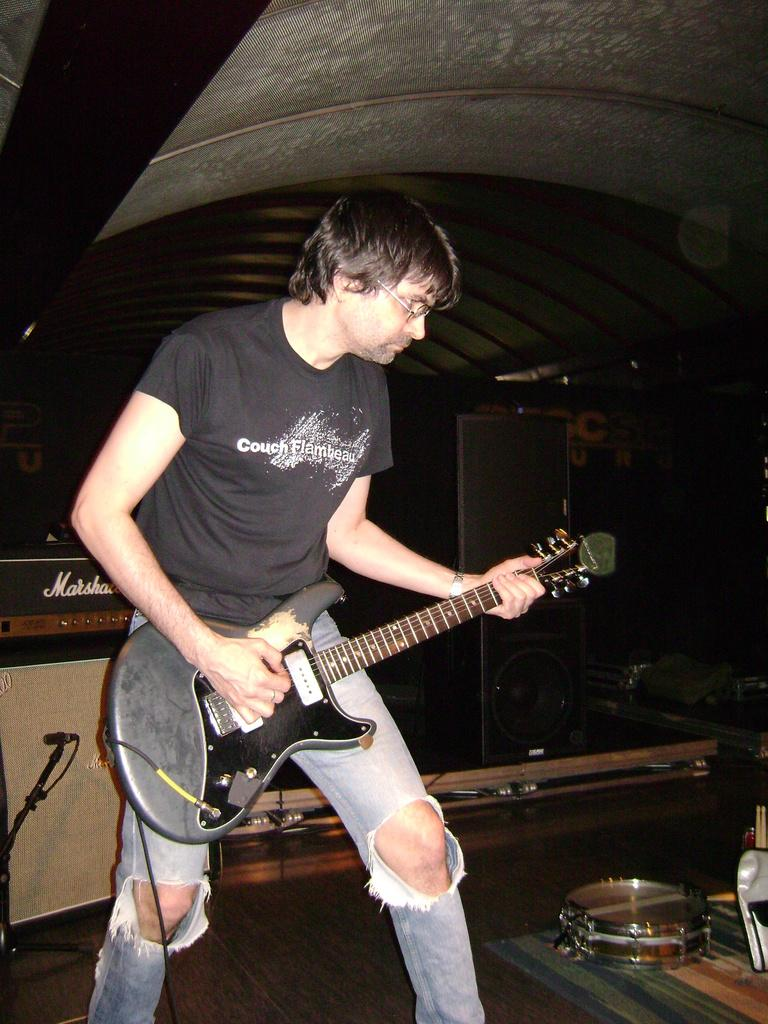What is the man in the image doing? The man is playing a guitar in the image. What can be seen in the background of the image? There is a speaker in the background of the image. What other musical instrument is visible in the image? There is a drum on the right side of the image. What type of umbrella is the man holding while playing the guitar? There is no umbrella present in the image; the man is only playing the guitar. What badge is the man wearing while playing the guitar? There is no badge mentioned or visible in the image; the man is simply playing the guitar. 